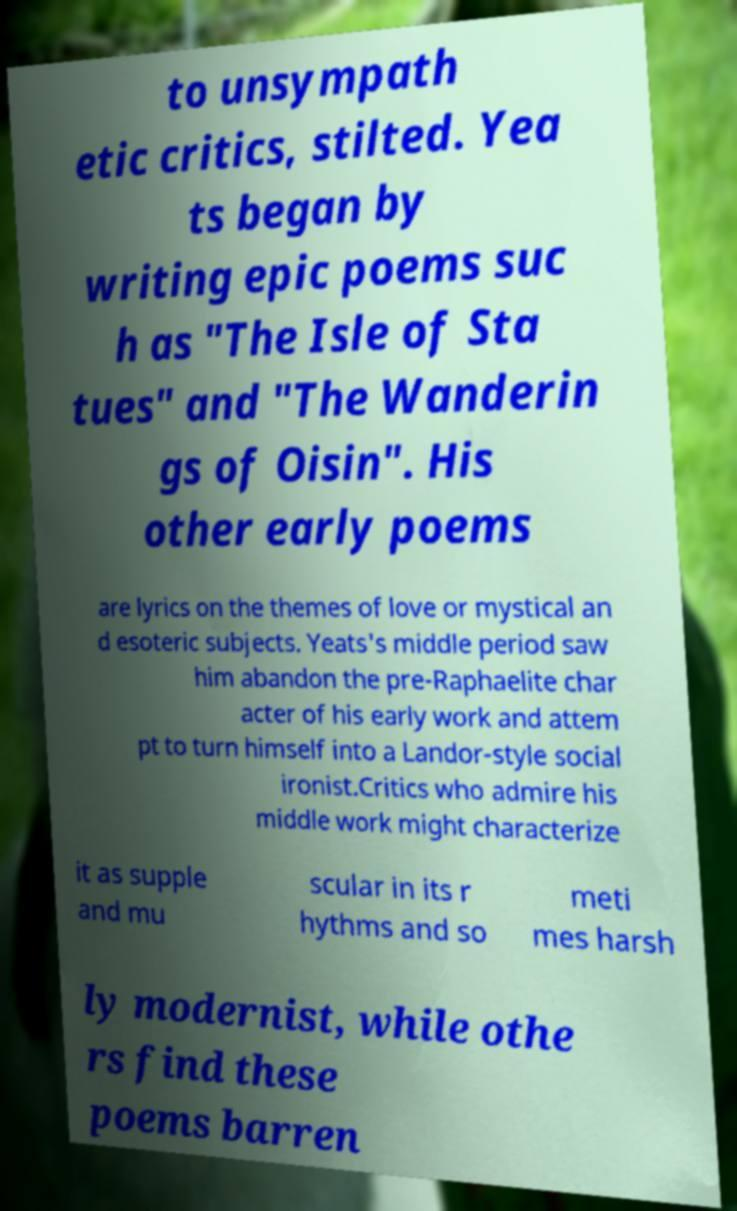There's text embedded in this image that I need extracted. Can you transcribe it verbatim? to unsympath etic critics, stilted. Yea ts began by writing epic poems suc h as "The Isle of Sta tues" and "The Wanderin gs of Oisin". His other early poems are lyrics on the themes of love or mystical an d esoteric subjects. Yeats's middle period saw him abandon the pre-Raphaelite char acter of his early work and attem pt to turn himself into a Landor-style social ironist.Critics who admire his middle work might characterize it as supple and mu scular in its r hythms and so meti mes harsh ly modernist, while othe rs find these poems barren 